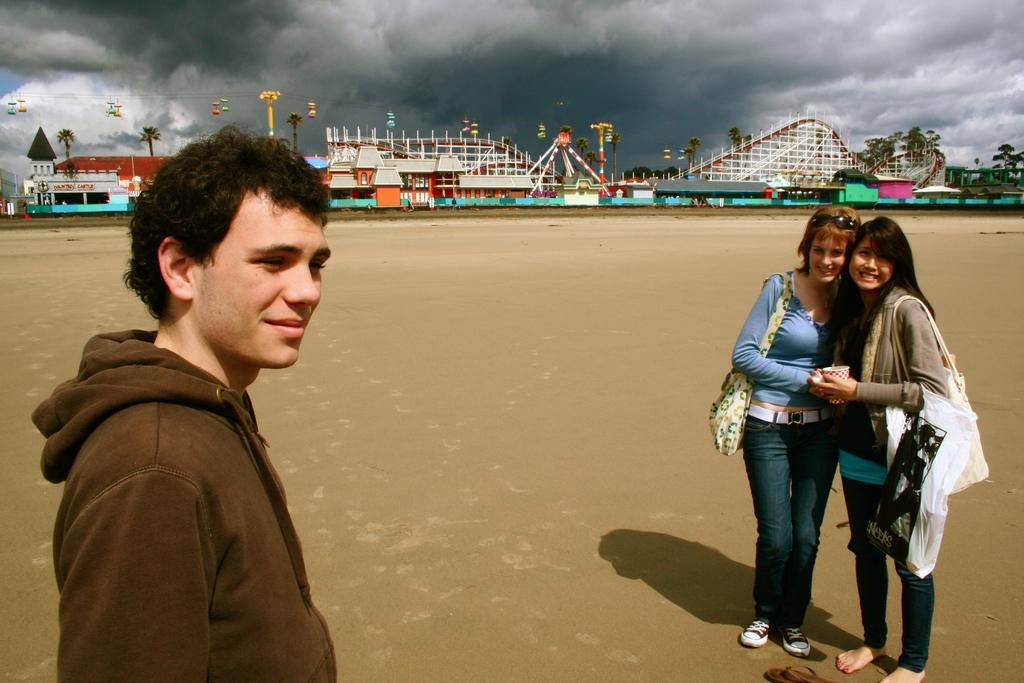Describe this image in one or two sentences. In this image on the right side there are two girls who are standing, and they are wearing bags. On the left side there is one person who is standing, and in the background we could see some buildings, bridge, poles, lights, trees. At the bottom there is a sand and on the top of the image there is sky. 